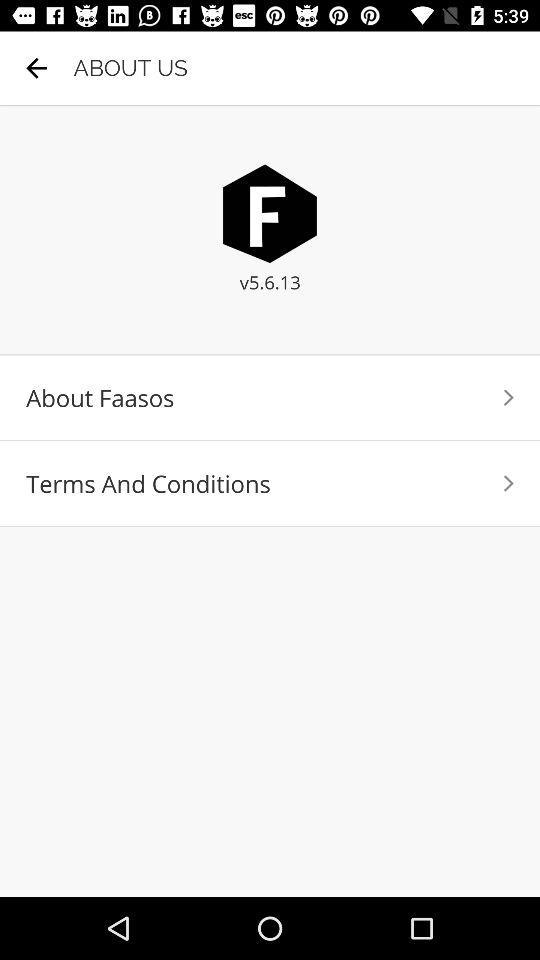What is the version of the application? The version is 5.6.13. 